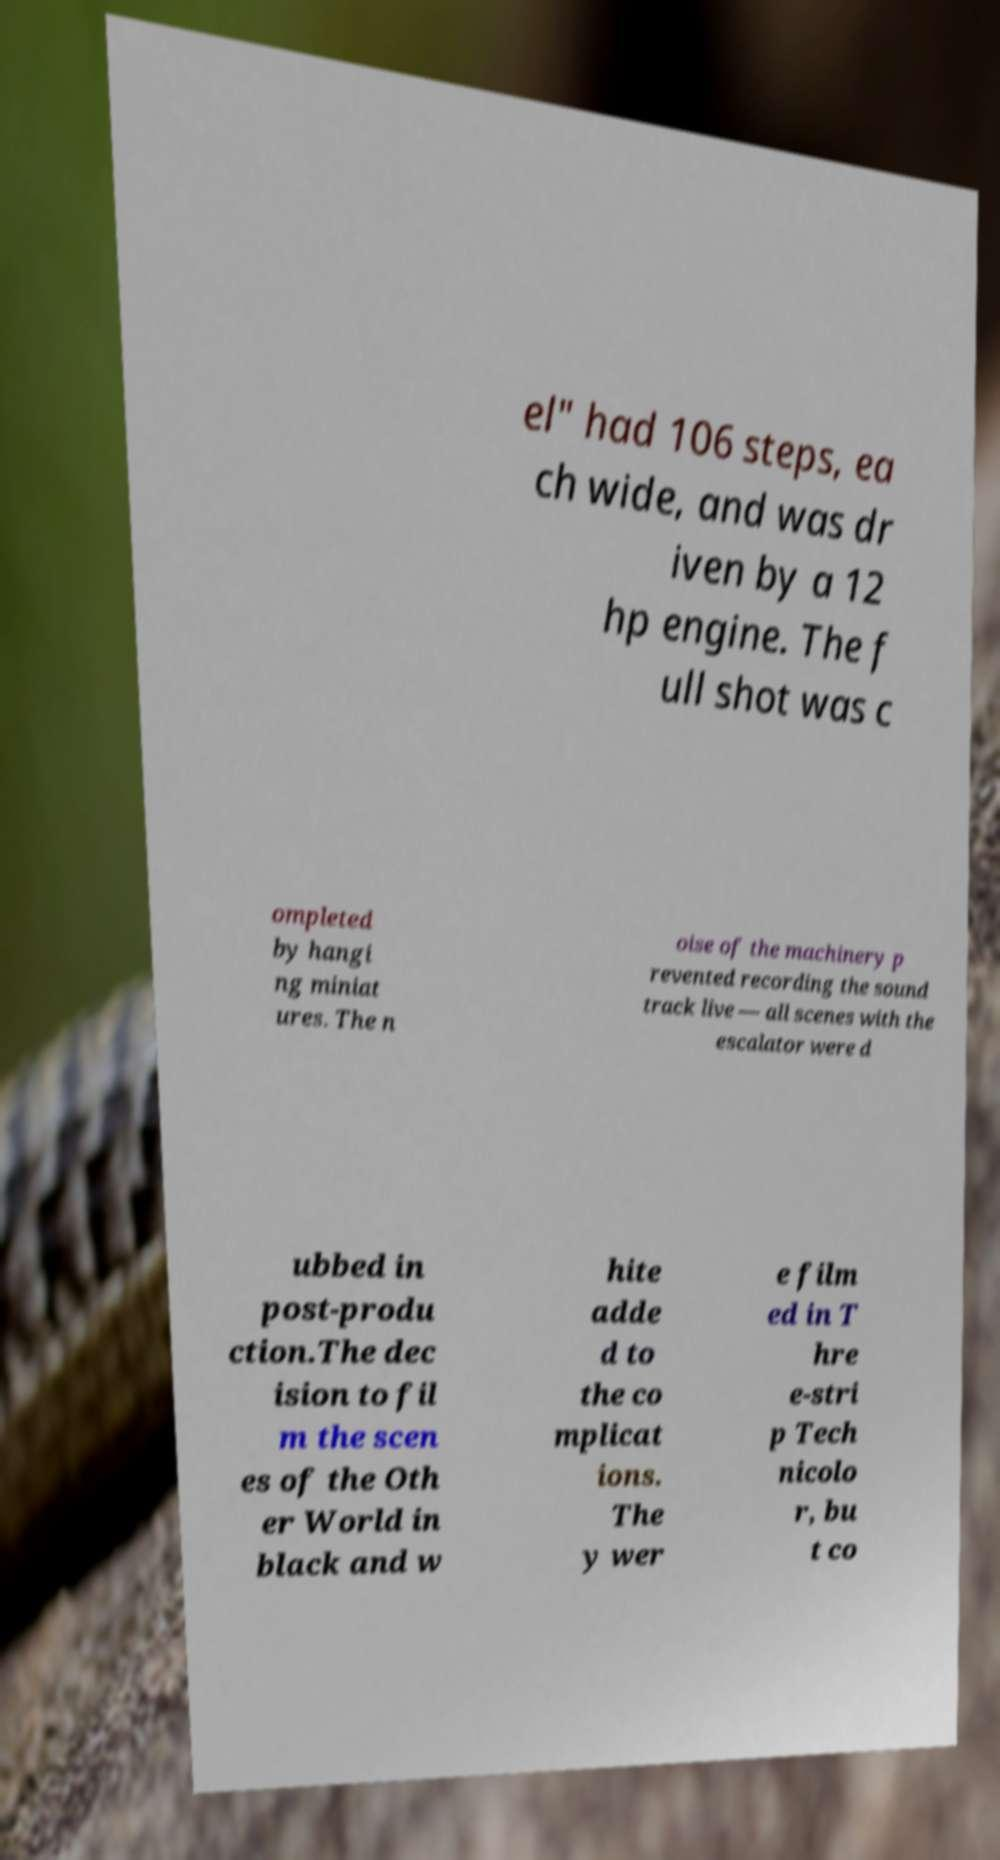Can you read and provide the text displayed in the image?This photo seems to have some interesting text. Can you extract and type it out for me? el" had 106 steps, ea ch wide, and was dr iven by a 12 hp engine. The f ull shot was c ompleted by hangi ng miniat ures. The n oise of the machinery p revented recording the sound track live — all scenes with the escalator were d ubbed in post-produ ction.The dec ision to fil m the scen es of the Oth er World in black and w hite adde d to the co mplicat ions. The y wer e film ed in T hre e-stri p Tech nicolo r, bu t co 